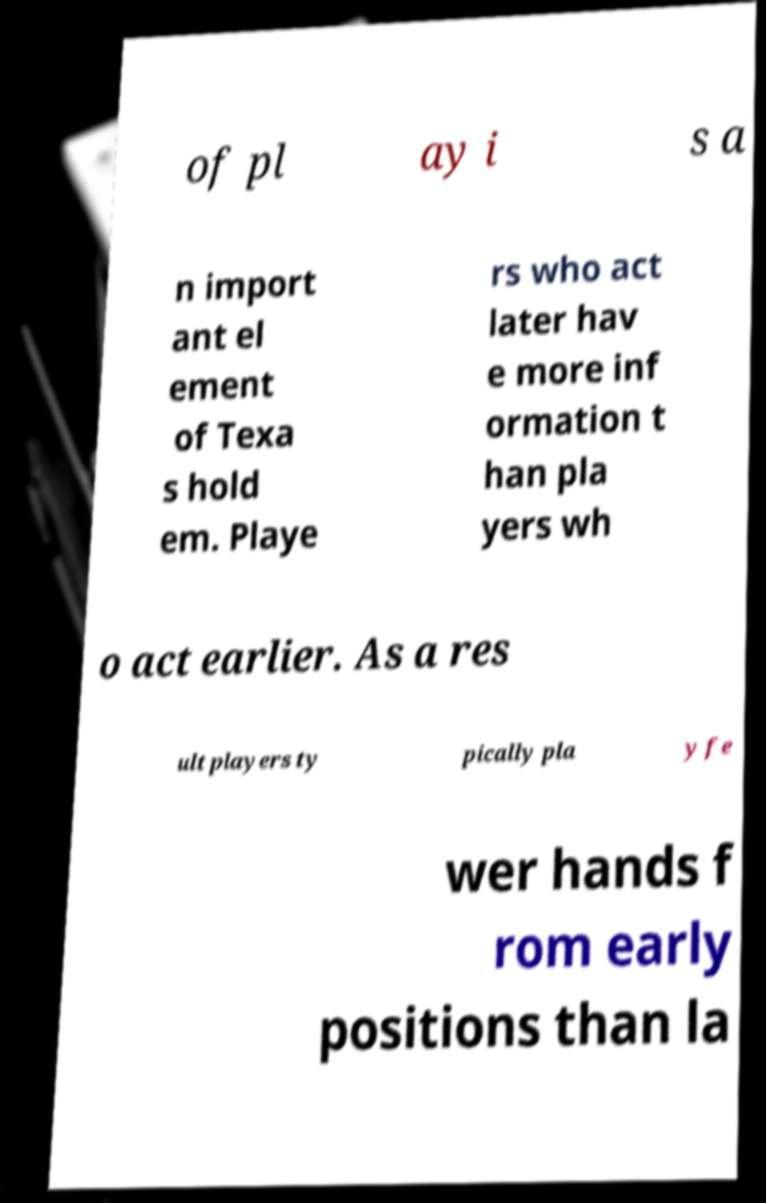Please identify and transcribe the text found in this image. of pl ay i s a n import ant el ement of Texa s hold em. Playe rs who act later hav e more inf ormation t han pla yers wh o act earlier. As a res ult players ty pically pla y fe wer hands f rom early positions than la 